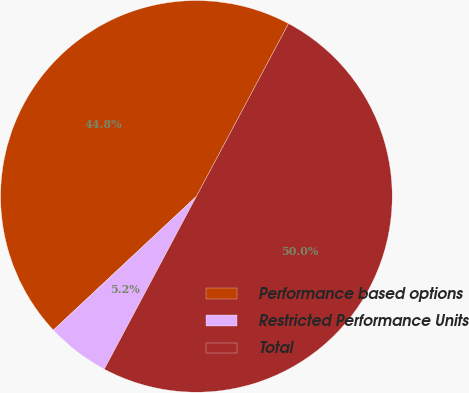Convert chart. <chart><loc_0><loc_0><loc_500><loc_500><pie_chart><fcel>Performance based options<fcel>Restricted Performance Units<fcel>Total<nl><fcel>44.76%<fcel>5.24%<fcel>50.0%<nl></chart> 